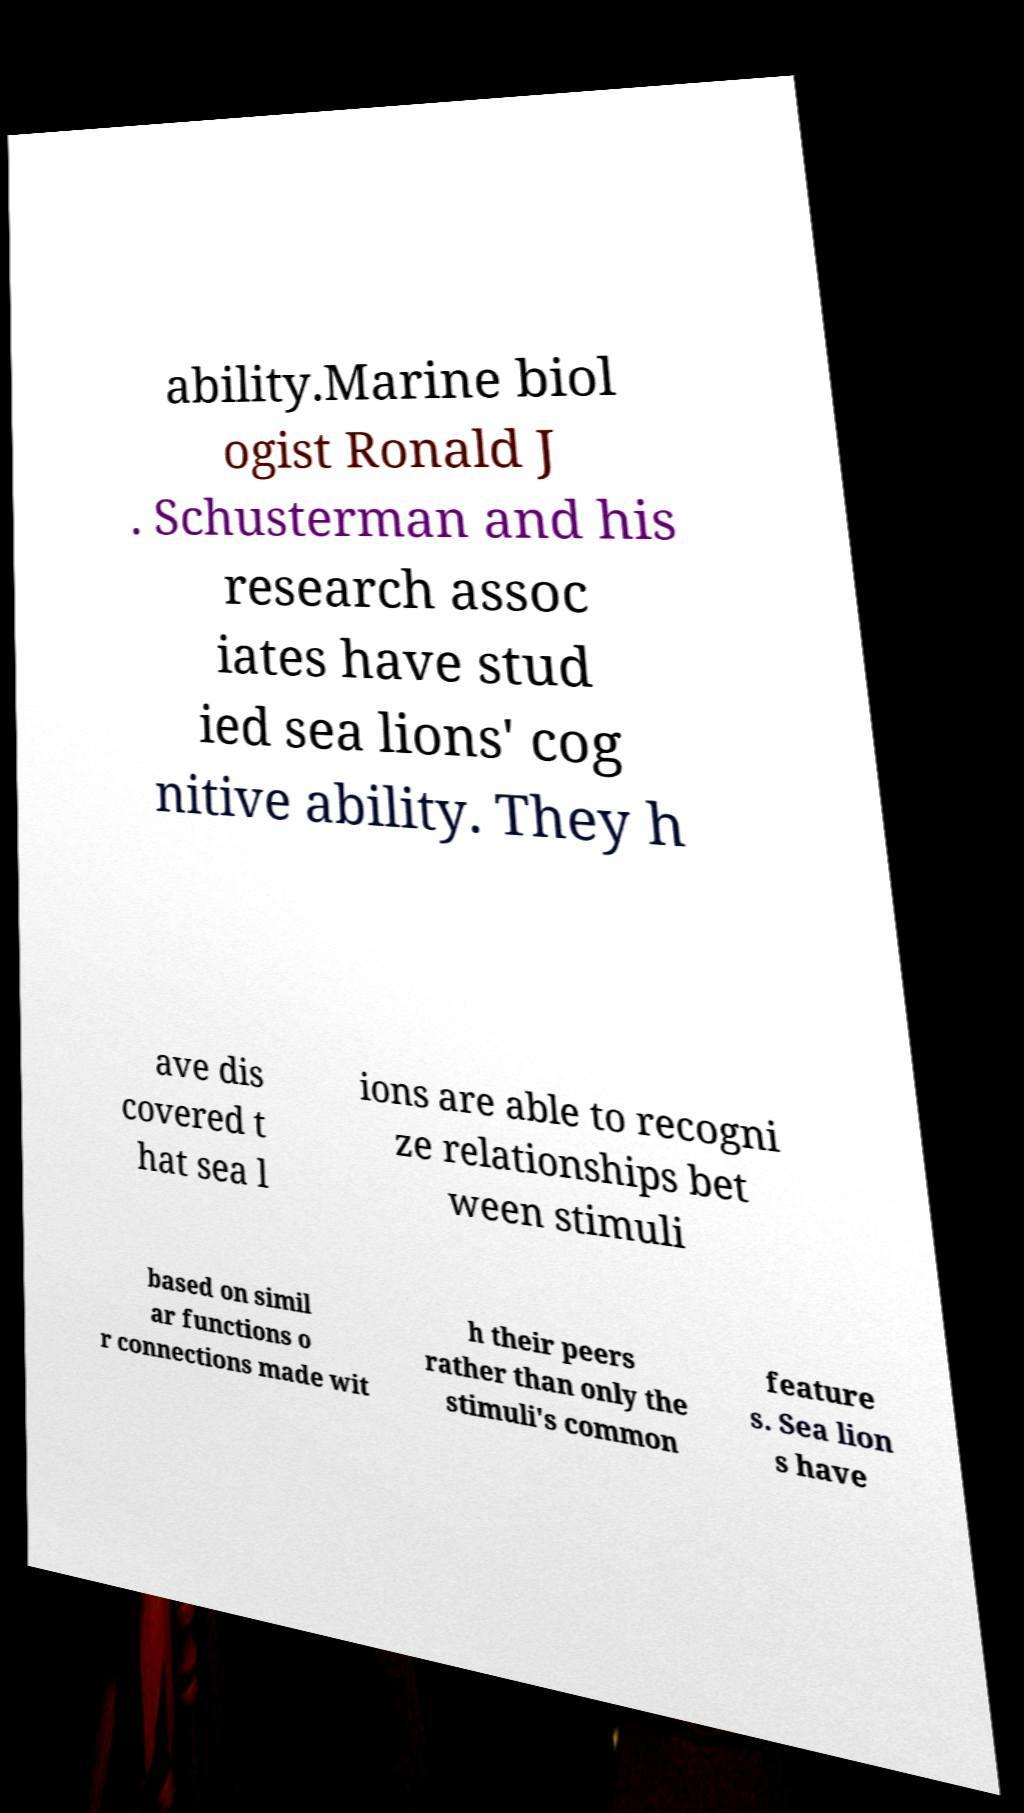What messages or text are displayed in this image? I need them in a readable, typed format. ability.Marine biol ogist Ronald J . Schusterman and his research assoc iates have stud ied sea lions' cog nitive ability. They h ave dis covered t hat sea l ions are able to recogni ze relationships bet ween stimuli based on simil ar functions o r connections made wit h their peers rather than only the stimuli's common feature s. Sea lion s have 